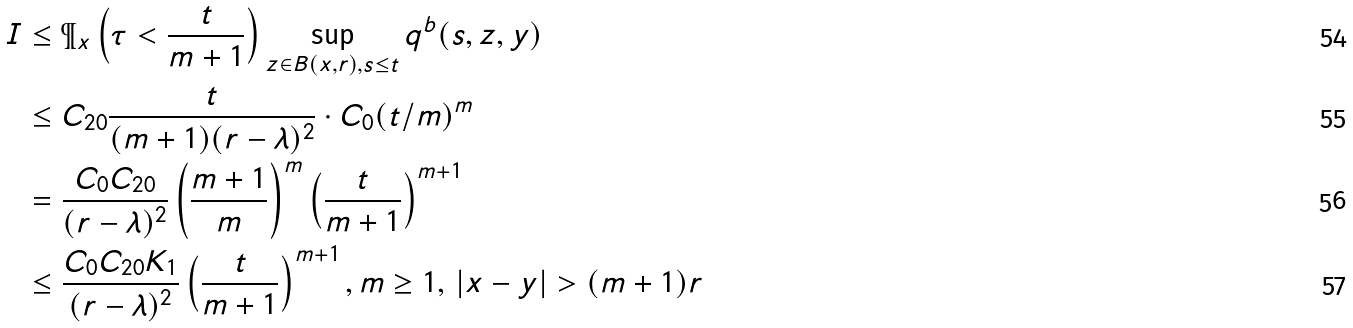<formula> <loc_0><loc_0><loc_500><loc_500>I & \leq \P _ { x } \left ( \tau < \frac { t } { m + 1 } \right ) \sup _ { z \in B ( x , r ) , s \leq t } q ^ { b } ( s , z , y ) \\ & \leq C _ { 2 0 } \frac { t } { ( m + 1 ) ( r - \lambda ) ^ { 2 } } \cdot C _ { 0 } ( t / m ) ^ { m } \\ & = \frac { C _ { 0 } C _ { 2 0 } } { ( r - \lambda ) ^ { 2 } } \left ( \frac { m + 1 } { m } \right ) ^ { m } \left ( \frac { t } { m + 1 } \right ) ^ { m + 1 } \\ & \leq \frac { C _ { 0 } C _ { 2 0 } K _ { 1 } } { ( r - \lambda ) ^ { 2 } } \left ( \frac { t } { m + 1 } \right ) ^ { m + 1 } , m \geq 1 , \, | x - y | > ( m + 1 ) r</formula> 